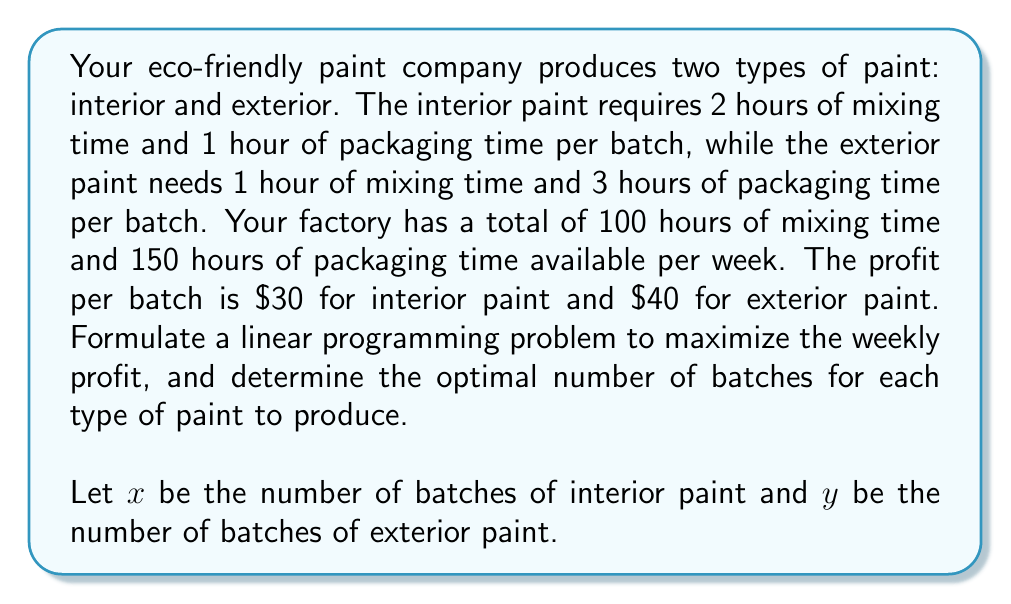Can you answer this question? To solve this linear programming problem, we'll follow these steps:

1. Formulate the objective function:
   The objective is to maximize profit. Let $P$ be the total profit.
   $$P = 30x + 40y$$

2. Identify the constraints:
   a) Mixing time constraint: $2x + y \leq 100$
   b) Packaging time constraint: $x + 3y \leq 150$
   c) Non-negativity constraints: $x \geq 0, y \geq 0$

3. Graph the constraints:
   [asy]
   import geometry;
   
   size(200);
   
   real xmax = 100;
   real ymax = 75;
   
   xaxis("x", 0, xmax, arrow=Arrow);
   yaxis("y", 0, ymax, arrow=Arrow);
   
   draw((0,100)--(50,0), blue);
   draw((0,50)--(150,0), red);
   
   label("2x + y = 100", (25,50), NE, blue);
   label("x + 3y = 150", (75,25), SE, red);
   
   fill((0,0)--(0,50)--(50,0)--cycle, palegreen+opacity(0.2));
   
   dot((0,50));
   dot((50,0));
   dot((30,30));
   
   label("(0,50)", (0,50), W);
   label("(50,0)", (50,0), S);
   label("(30,30)", (30,30), NE);
   [/asy]

4. Identify the feasible region:
   The feasible region is the green shaded area bounded by the constraints.

5. Find the vertices of the feasible region:
   a) (0,0)
   b) (0,50)
   c) (50,0)
   d) Intersection of $2x + y = 100$ and $x + 3y = 150$:
      Solving these equations simultaneously:
      $2x + y = 100$
      $x + 3y = 150$
      Subtracting the first equation from the second:
      $2y = 50$
      $y = 25$
      Substituting back:
      $2x + 25 = 100$
      $x = 37.5$
      So, the intersection point is (37.5, 25)

6. Evaluate the objective function at each vertex:
   a) P(0,0) = 0
   b) P(0,50) = 40 * 50 = 2000
   c) P(50,0) = 30 * 50 = 1500
   d) P(37.5,25) = 30 * 37.5 + 40 * 25 = 2125

7. The maximum profit occurs at the point (37.5, 25).

However, since we can't produce fractional batches, we need to round down to the nearest integer:
x = 37 batches of interior paint
y = 25 batches of exterior paint

8. Calculate the maximum profit:
   $P = 30 * 37 + 40 * 25 = 1110 + 1000 = 2110$
Answer: The optimal production schedule is to produce 37 batches of interior paint and 25 batches of exterior paint per week, resulting in a maximum profit of $2110. 